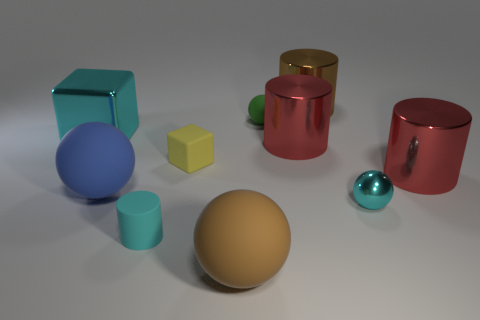Subtract all rubber spheres. How many spheres are left? 1 Subtract all red cylinders. How many cylinders are left? 2 Subtract 1 spheres. How many spheres are left? 3 Subtract all red balls. Subtract all gray cubes. How many balls are left? 4 Subtract all yellow cubes. How many green spheres are left? 1 Add 5 cyan spheres. How many cyan spheres are left? 6 Add 5 cyan shiny blocks. How many cyan shiny blocks exist? 6 Subtract 1 yellow blocks. How many objects are left? 9 Subtract all cylinders. How many objects are left? 6 Subtract all large brown metal objects. Subtract all brown spheres. How many objects are left? 8 